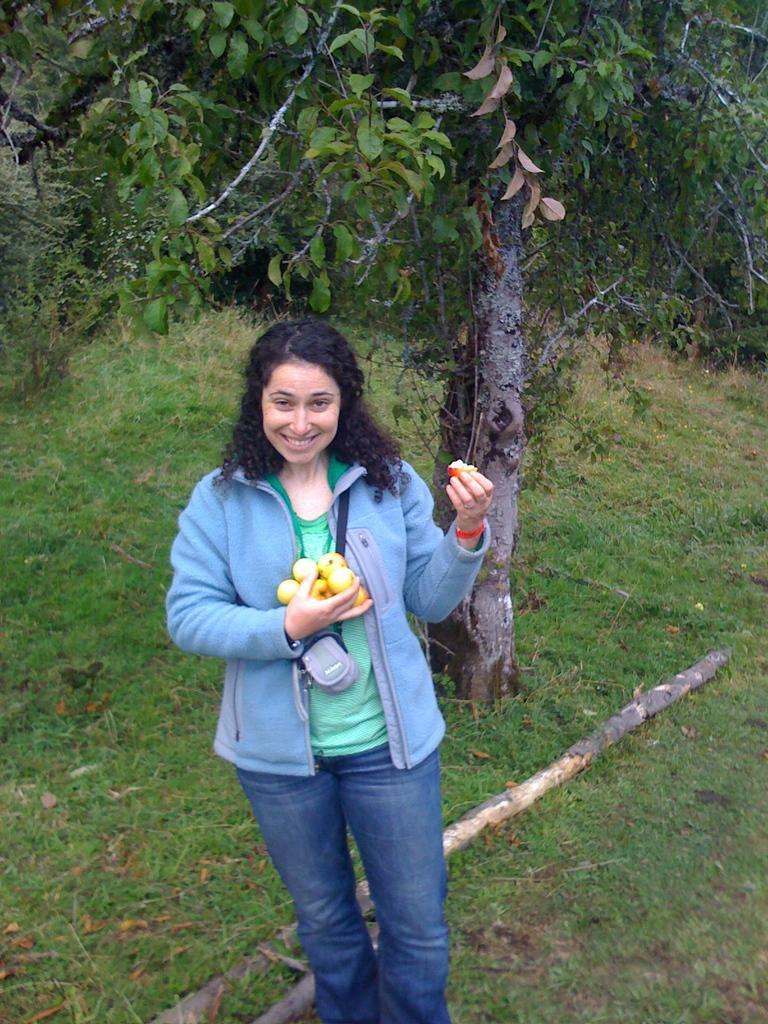Could you give a brief overview of what you see in this image? In this picture there is a girl in the center of the image, by holding fruits in her hands and there is greenery in the background area of the image. 